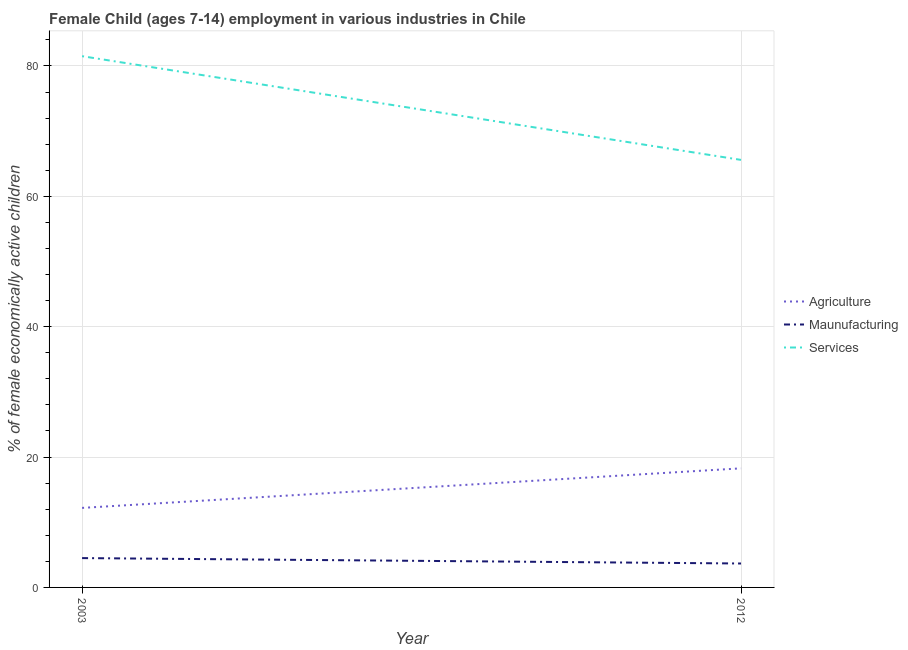How many different coloured lines are there?
Offer a terse response. 3. Does the line corresponding to percentage of economically active children in agriculture intersect with the line corresponding to percentage of economically active children in services?
Your answer should be compact. No. Is the number of lines equal to the number of legend labels?
Provide a succinct answer. Yes. What is the percentage of economically active children in services in 2012?
Keep it short and to the point. 65.59. Across all years, what is the maximum percentage of economically active children in services?
Make the answer very short. 81.5. Across all years, what is the minimum percentage of economically active children in services?
Provide a short and direct response. 65.59. In which year was the percentage of economically active children in services maximum?
Your answer should be very brief. 2003. What is the total percentage of economically active children in services in the graph?
Your response must be concise. 147.09. What is the difference between the percentage of economically active children in services in 2003 and that in 2012?
Ensure brevity in your answer.  15.91. What is the difference between the percentage of economically active children in manufacturing in 2012 and the percentage of economically active children in services in 2003?
Your answer should be very brief. -77.83. What is the average percentage of economically active children in agriculture per year?
Make the answer very short. 15.23. In the year 2012, what is the difference between the percentage of economically active children in services and percentage of economically active children in agriculture?
Your response must be concise. 47.32. What is the ratio of the percentage of economically active children in agriculture in 2003 to that in 2012?
Offer a very short reply. 0.67. Does the percentage of economically active children in services monotonically increase over the years?
Make the answer very short. No. Is the percentage of economically active children in agriculture strictly greater than the percentage of economically active children in services over the years?
Keep it short and to the point. No. Are the values on the major ticks of Y-axis written in scientific E-notation?
Provide a succinct answer. No. Does the graph contain any zero values?
Provide a succinct answer. No. Does the graph contain grids?
Provide a succinct answer. Yes. How many legend labels are there?
Ensure brevity in your answer.  3. What is the title of the graph?
Your answer should be compact. Female Child (ages 7-14) employment in various industries in Chile. Does "Ages 50+" appear as one of the legend labels in the graph?
Your answer should be very brief. No. What is the label or title of the X-axis?
Ensure brevity in your answer.  Year. What is the label or title of the Y-axis?
Keep it short and to the point. % of female economically active children. What is the % of female economically active children of Services in 2003?
Your answer should be compact. 81.5. What is the % of female economically active children of Agriculture in 2012?
Provide a succinct answer. 18.27. What is the % of female economically active children in Maunufacturing in 2012?
Keep it short and to the point. 3.67. What is the % of female economically active children of Services in 2012?
Your answer should be compact. 65.59. Across all years, what is the maximum % of female economically active children of Agriculture?
Your answer should be compact. 18.27. Across all years, what is the maximum % of female economically active children of Services?
Make the answer very short. 81.5. Across all years, what is the minimum % of female economically active children in Maunufacturing?
Offer a very short reply. 3.67. Across all years, what is the minimum % of female economically active children of Services?
Provide a succinct answer. 65.59. What is the total % of female economically active children of Agriculture in the graph?
Make the answer very short. 30.47. What is the total % of female economically active children of Maunufacturing in the graph?
Make the answer very short. 8.17. What is the total % of female economically active children of Services in the graph?
Ensure brevity in your answer.  147.09. What is the difference between the % of female economically active children of Agriculture in 2003 and that in 2012?
Your response must be concise. -6.07. What is the difference between the % of female economically active children of Maunufacturing in 2003 and that in 2012?
Your answer should be very brief. 0.83. What is the difference between the % of female economically active children of Services in 2003 and that in 2012?
Provide a short and direct response. 15.91. What is the difference between the % of female economically active children in Agriculture in 2003 and the % of female economically active children in Maunufacturing in 2012?
Your answer should be very brief. 8.53. What is the difference between the % of female economically active children in Agriculture in 2003 and the % of female economically active children in Services in 2012?
Give a very brief answer. -53.39. What is the difference between the % of female economically active children of Maunufacturing in 2003 and the % of female economically active children of Services in 2012?
Make the answer very short. -61.09. What is the average % of female economically active children of Agriculture per year?
Provide a succinct answer. 15.23. What is the average % of female economically active children in Maunufacturing per year?
Keep it short and to the point. 4.08. What is the average % of female economically active children of Services per year?
Offer a very short reply. 73.55. In the year 2003, what is the difference between the % of female economically active children in Agriculture and % of female economically active children in Maunufacturing?
Your answer should be compact. 7.7. In the year 2003, what is the difference between the % of female economically active children in Agriculture and % of female economically active children in Services?
Keep it short and to the point. -69.3. In the year 2003, what is the difference between the % of female economically active children in Maunufacturing and % of female economically active children in Services?
Your answer should be very brief. -77. In the year 2012, what is the difference between the % of female economically active children in Agriculture and % of female economically active children in Maunufacturing?
Your answer should be compact. 14.6. In the year 2012, what is the difference between the % of female economically active children in Agriculture and % of female economically active children in Services?
Your answer should be very brief. -47.32. In the year 2012, what is the difference between the % of female economically active children of Maunufacturing and % of female economically active children of Services?
Make the answer very short. -61.92. What is the ratio of the % of female economically active children in Agriculture in 2003 to that in 2012?
Provide a succinct answer. 0.67. What is the ratio of the % of female economically active children in Maunufacturing in 2003 to that in 2012?
Your answer should be very brief. 1.23. What is the ratio of the % of female economically active children in Services in 2003 to that in 2012?
Your answer should be compact. 1.24. What is the difference between the highest and the second highest % of female economically active children of Agriculture?
Give a very brief answer. 6.07. What is the difference between the highest and the second highest % of female economically active children in Maunufacturing?
Make the answer very short. 0.83. What is the difference between the highest and the second highest % of female economically active children in Services?
Your answer should be compact. 15.91. What is the difference between the highest and the lowest % of female economically active children in Agriculture?
Your answer should be very brief. 6.07. What is the difference between the highest and the lowest % of female economically active children in Maunufacturing?
Offer a terse response. 0.83. What is the difference between the highest and the lowest % of female economically active children of Services?
Your answer should be very brief. 15.91. 